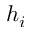Convert formula to latex. <formula><loc_0><loc_0><loc_500><loc_500>h _ { i }</formula> 